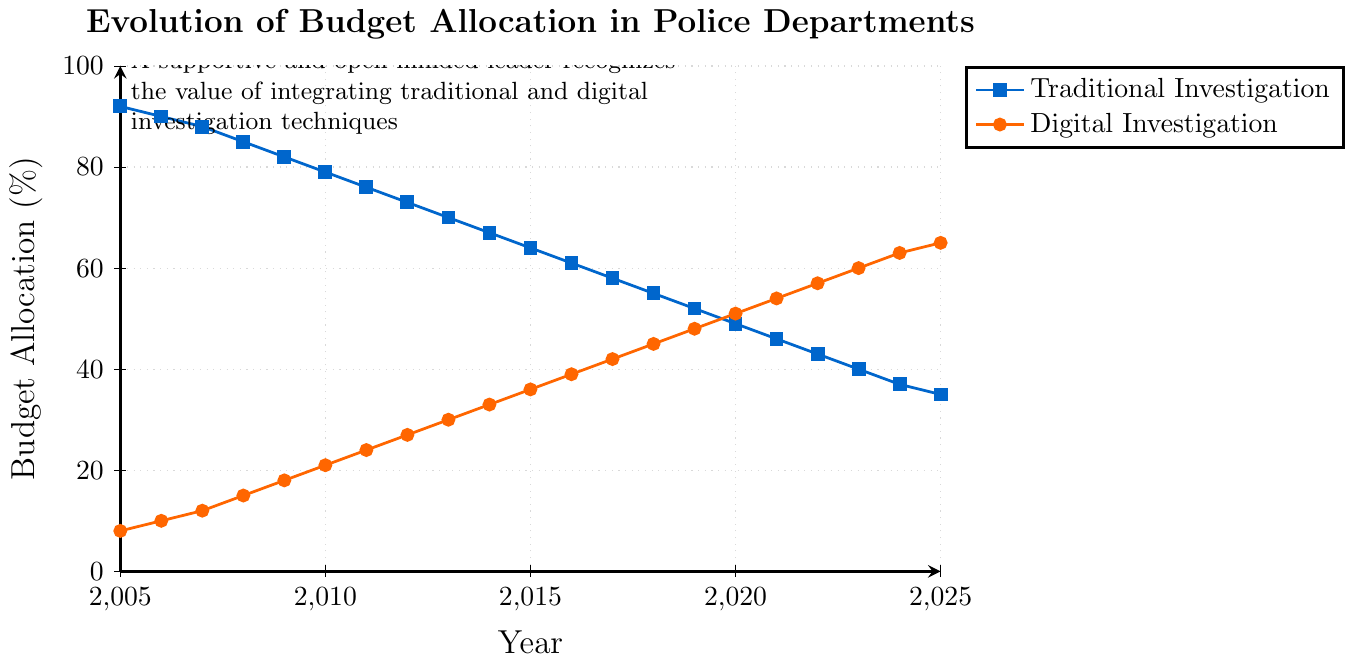What's the percentage allocation to digital investigation in 2015? For 2015, refer to the point on the line representing Digital Investigation. The y-value at the 2015 x-coordinate is 36%.
Answer: 36% What was the decrease in traditional investigation budget allocation from 2010 to 2015? Identify the budget percentage for traditional investigation in both years: 79% in 2010 and 64% in 2015. Subtract the 2015 value from the 2010 value: 79% - 64% = 15%.
Answer: 15% In which year did the budget for digital investigation first equal or exceed 50%? Locate where the digital investigation line intersects 50% on the y-axis. This occurs in 2020.
Answer: 2020 What's the difference in budget allocation for traditional investigation between 2005 and 2010? Identify the budget allocation in each year: 92% in 2005 and 79% in 2010. Calculate the difference: 92% - 79% = 13%.
Answer: 13% Which investigation technique had the higher budget allocation in 2021, and by how much? Check 2021 values: Traditional: 46%, Digital: 54%. Digital is greater, and the difference is 54% - 46% = 8%.
Answer: Digital by 8% What is the average budget allocation for digital investigation from 2010 to 2015? Identify yearly percentages: 2010: 21%, 2011: 24%, 2012: 27%, 2013: 30%, 2014: 33%, 2015: 36%. Calculate the sum and divide by the number of years: (21% + 24% + 27% + 30% + 33% + 36%) / 6 = 28.5%.
Answer: 28.5% During which five-year period did the budget for traditional investigation decrease the most? Calculate the five-year decrease for each period:
2005-2010: 92% to 79% = 13%
2010-2015: 79% to 64% = 15%
2015-2020: 64% to 49% = 15%
2020-2025: 49% to 35% = 14%
The most significant decrease is in two periods: 2010-2015 and 2015-2020, both with a 15% decrease.
Answer: 2010-2015 and 2015-2020 Comparing the budget allocation trends, which type of investigation shows a steady increase, and what might that imply? Observe the continuous upward trend in the digital investigation line from 8% in 2005 to 65% in 2025. This indicates increasing importance and investment in digital investigation techniques.
Answer: Digital, implies increasing importance 